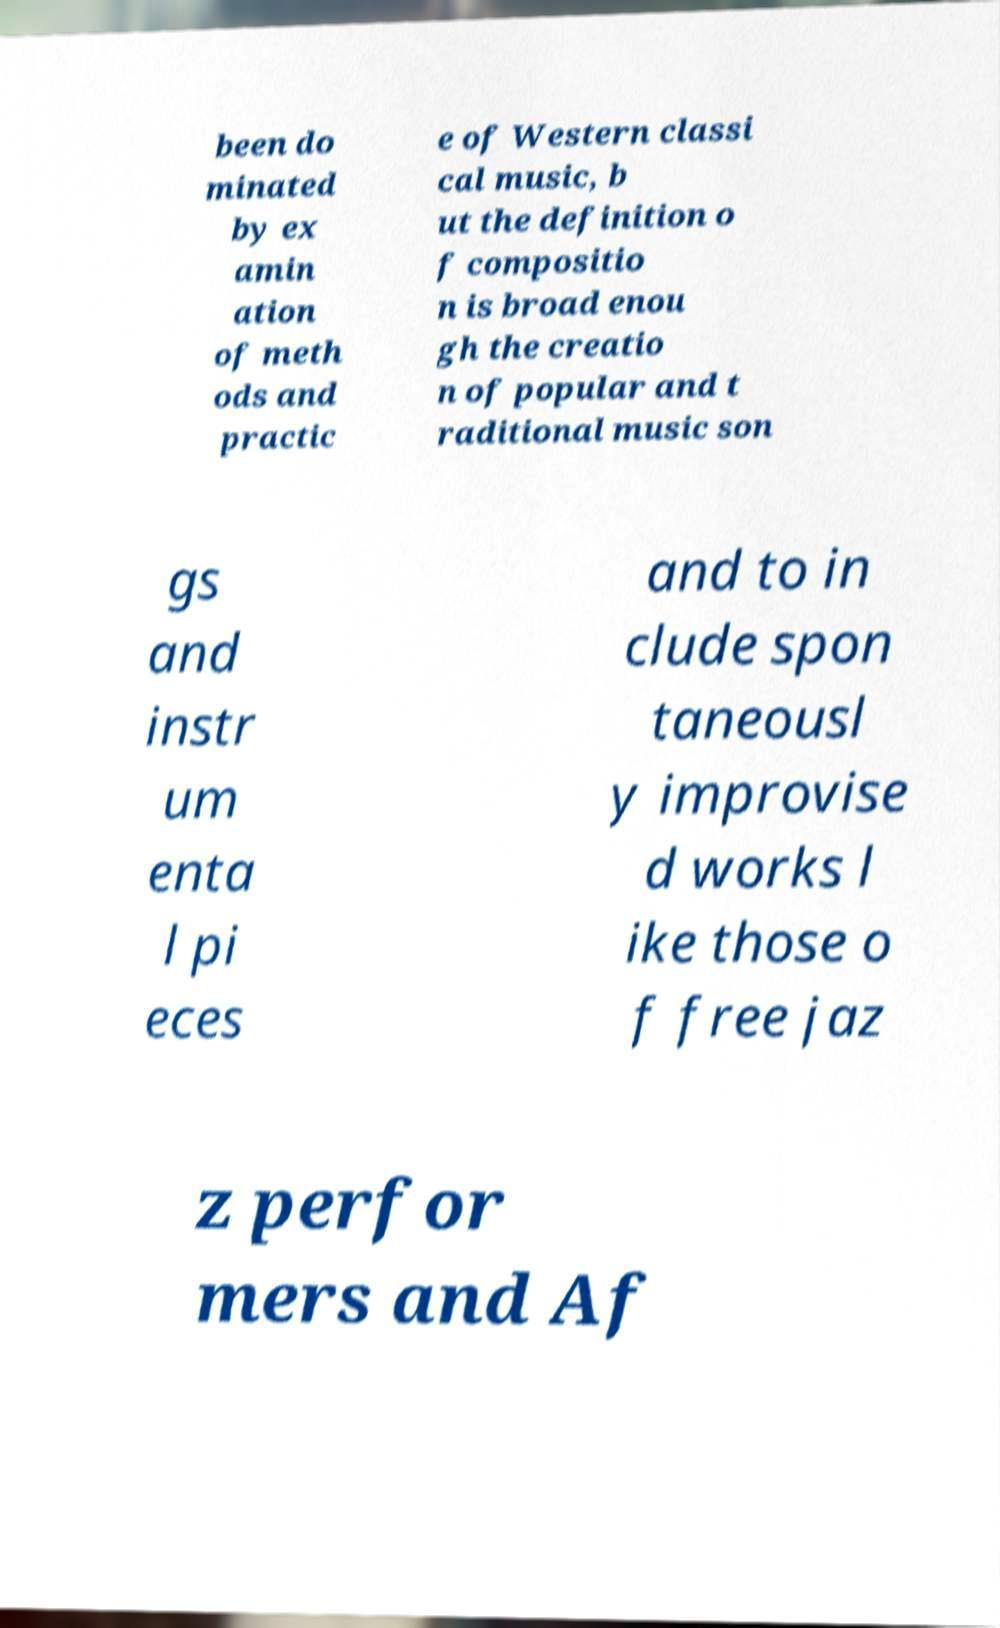I need the written content from this picture converted into text. Can you do that? been do minated by ex amin ation of meth ods and practic e of Western classi cal music, b ut the definition o f compositio n is broad enou gh the creatio n of popular and t raditional music son gs and instr um enta l pi eces and to in clude spon taneousl y improvise d works l ike those o f free jaz z perfor mers and Af 